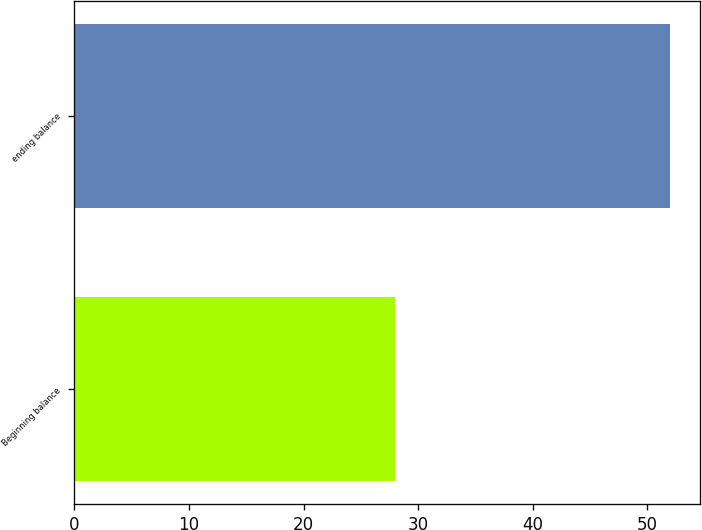<chart> <loc_0><loc_0><loc_500><loc_500><bar_chart><fcel>Beginning balance<fcel>ending balance<nl><fcel>28<fcel>52<nl></chart> 